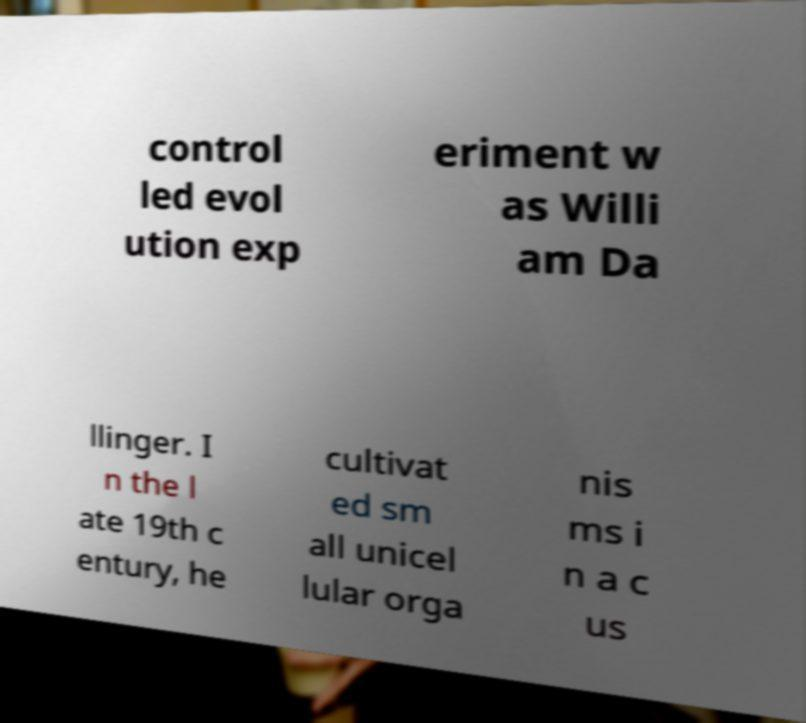Please identify and transcribe the text found in this image. control led evol ution exp eriment w as Willi am Da llinger. I n the l ate 19th c entury, he cultivat ed sm all unicel lular orga nis ms i n a c us 